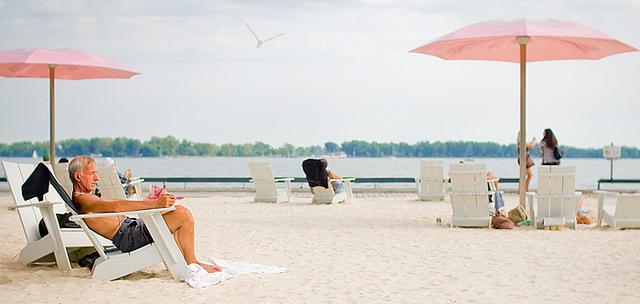Where are the people?
Keep it brief. Beach. Is the man burned?
Answer briefly. No. How many towels are in the picture?
Keep it brief. 2. Is it warm there?
Short answer required. Yes. How many umbrellas are there?
Keep it brief. 2. What color are the umbrellas?
Concise answer only. Pink. 